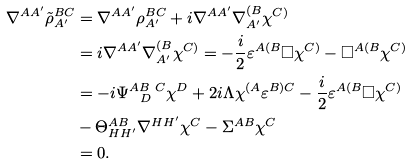<formula> <loc_0><loc_0><loc_500><loc_500>\nabla ^ { A A ^ { \prime } } \tilde { \rho } _ { A ^ { \prime } } ^ { B C } & = \nabla ^ { A A ^ { \prime } } \rho ^ { B C } _ { A ^ { \prime } } + i \nabla ^ { A A ^ { \prime } } \nabla ^ { ( B } _ { A ^ { \prime } } \chi ^ { C ) } \\ & = i \nabla ^ { A A ^ { \prime } } \nabla ^ { ( B } _ { A ^ { \prime } } \chi ^ { C ) } = - \frac { i } { 2 } \varepsilon ^ { A ( B } \square \chi ^ { C ) } - \square ^ { A ( B } \chi ^ { C ) } \\ & = - i \Psi ^ { A B \ C } _ { \ \ D } \chi ^ { D } + 2 i \Lambda \chi ^ { ( A } \varepsilon ^ { B ) C } - \frac { i } { 2 } \varepsilon ^ { A ( B } \square \chi ^ { C ) } \\ & - \Theta ^ { A B } _ { H H ^ { \prime } } \nabla ^ { H H ^ { \prime } } \chi ^ { C } - \Sigma ^ { A B } \chi ^ { C } \\ & = 0 .</formula> 